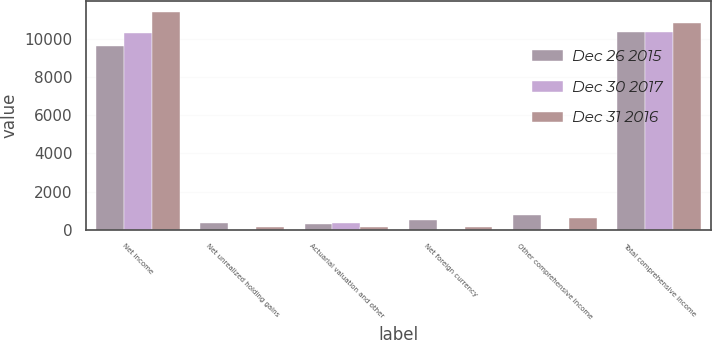Convert chart to OTSL. <chart><loc_0><loc_0><loc_500><loc_500><stacked_bar_chart><ecel><fcel>Net income<fcel>Net unrealized holding gains<fcel>Actuarial valuation and other<fcel>Net foreign currency<fcel>Other comprehensive income<fcel>Total comprehensive income<nl><fcel>Dec 26 2015<fcel>9601<fcel>365<fcel>317<fcel>510<fcel>756<fcel>10357<nl><fcel>Dec 30 2017<fcel>10316<fcel>7<fcel>364<fcel>4<fcel>46<fcel>10362<nl><fcel>Dec 31 2016<fcel>11420<fcel>157<fcel>135<fcel>170<fcel>606<fcel>10814<nl></chart> 